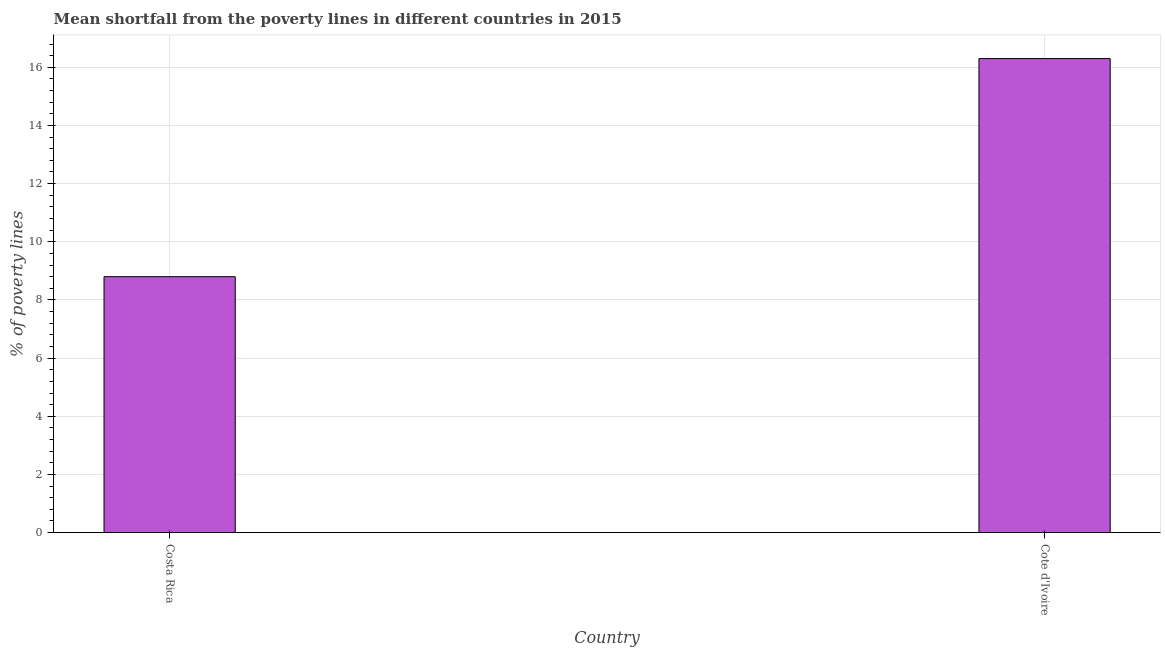What is the title of the graph?
Offer a very short reply. Mean shortfall from the poverty lines in different countries in 2015. What is the label or title of the X-axis?
Your answer should be compact. Country. What is the label or title of the Y-axis?
Keep it short and to the point. % of poverty lines. Across all countries, what is the maximum poverty gap at national poverty lines?
Your response must be concise. 16.3. Across all countries, what is the minimum poverty gap at national poverty lines?
Provide a short and direct response. 8.8. In which country was the poverty gap at national poverty lines maximum?
Keep it short and to the point. Cote d'Ivoire. In which country was the poverty gap at national poverty lines minimum?
Provide a succinct answer. Costa Rica. What is the sum of the poverty gap at national poverty lines?
Keep it short and to the point. 25.1. What is the difference between the poverty gap at national poverty lines in Costa Rica and Cote d'Ivoire?
Provide a short and direct response. -7.5. What is the average poverty gap at national poverty lines per country?
Your answer should be very brief. 12.55. What is the median poverty gap at national poverty lines?
Provide a short and direct response. 12.55. What is the ratio of the poverty gap at national poverty lines in Costa Rica to that in Cote d'Ivoire?
Your response must be concise. 0.54. Is the poverty gap at national poverty lines in Costa Rica less than that in Cote d'Ivoire?
Give a very brief answer. Yes. How many bars are there?
Provide a succinct answer. 2. Are all the bars in the graph horizontal?
Provide a succinct answer. No. What is the % of poverty lines in Costa Rica?
Your response must be concise. 8.8. What is the % of poverty lines in Cote d'Ivoire?
Provide a succinct answer. 16.3. What is the ratio of the % of poverty lines in Costa Rica to that in Cote d'Ivoire?
Offer a very short reply. 0.54. 